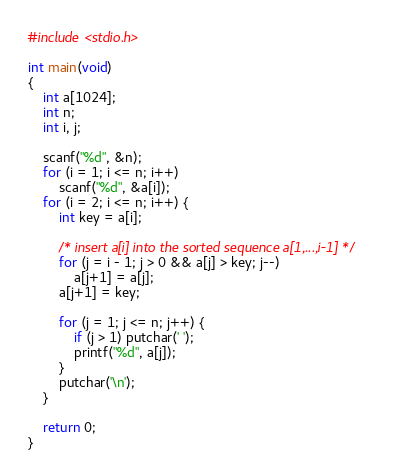Convert code to text. <code><loc_0><loc_0><loc_500><loc_500><_C_>#include <stdio.h>

int main(void)
{
	int a[1024];
	int n;
	int i, j;

	scanf("%d", &n);
	for (i = 1; i <= n; i++)
		scanf("%d", &a[i]);
	for (i = 2; i <= n; i++) {
		int key = a[i];

		/* insert a[i] into the sorted sequence a[1,...,i-1] */
		for (j = i - 1; j > 0 && a[j] > key; j--)
			a[j+1] = a[j];
		a[j+1] = key;

		for (j = 1; j <= n; j++) {
			if (j > 1) putchar(' ');
			printf("%d", a[j]); 
		}
		putchar('\n');
	}

	return 0;
}</code> 